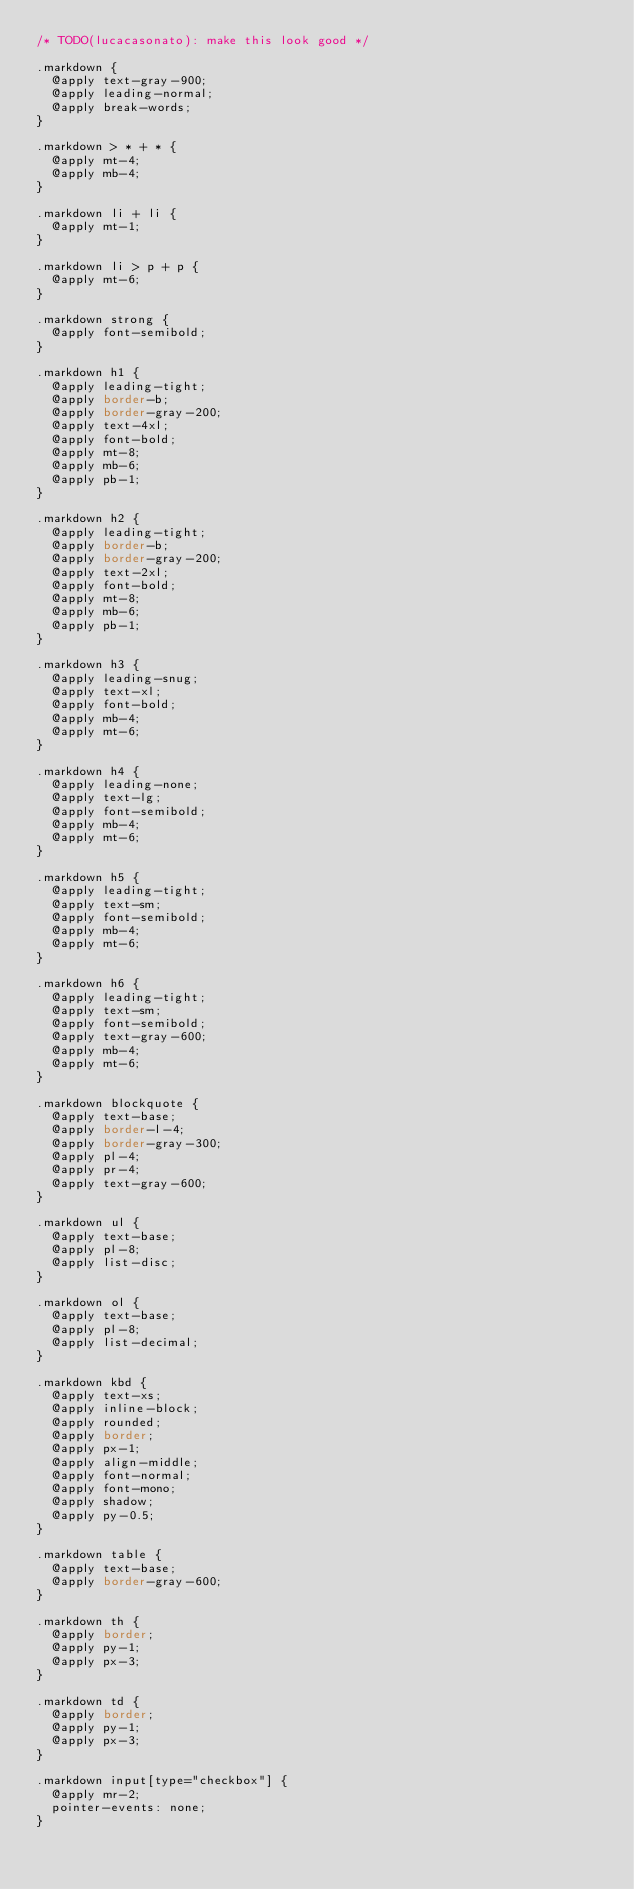Convert code to text. <code><loc_0><loc_0><loc_500><loc_500><_CSS_>/* TODO(lucacasonato): make this look good */

.markdown {
  @apply text-gray-900;
  @apply leading-normal;
  @apply break-words;
}

.markdown > * + * {
  @apply mt-4;
  @apply mb-4;
}

.markdown li + li {
  @apply mt-1;
}

.markdown li > p + p {
  @apply mt-6;
}

.markdown strong {
  @apply font-semibold;
}

.markdown h1 {
  @apply leading-tight;
  @apply border-b;
  @apply border-gray-200;
  @apply text-4xl;
  @apply font-bold;
  @apply mt-8;
  @apply mb-6;
  @apply pb-1;
}

.markdown h2 {
  @apply leading-tight;
  @apply border-b;
  @apply border-gray-200;
  @apply text-2xl;
  @apply font-bold;
  @apply mt-8;
  @apply mb-6;
  @apply pb-1;
}

.markdown h3 {
  @apply leading-snug;
  @apply text-xl;
  @apply font-bold;
  @apply mb-4;
  @apply mt-6;
}

.markdown h4 {
  @apply leading-none;
  @apply text-lg;
  @apply font-semibold;
  @apply mb-4;
  @apply mt-6;
}

.markdown h5 {
  @apply leading-tight;
  @apply text-sm;
  @apply font-semibold;
  @apply mb-4;
  @apply mt-6;
}

.markdown h6 {
  @apply leading-tight;
  @apply text-sm;
  @apply font-semibold;
  @apply text-gray-600;
  @apply mb-4;
  @apply mt-6;
}

.markdown blockquote {
  @apply text-base;
  @apply border-l-4;
  @apply border-gray-300;
  @apply pl-4;
  @apply pr-4;
  @apply text-gray-600;
}

.markdown ul {
  @apply text-base;
  @apply pl-8;
  @apply list-disc;
}

.markdown ol {
  @apply text-base;
  @apply pl-8;
  @apply list-decimal;
}

.markdown kbd {
  @apply text-xs;
  @apply inline-block;
  @apply rounded;
  @apply border;
  @apply px-1;
  @apply align-middle;
  @apply font-normal;
  @apply font-mono;
  @apply shadow;
  @apply py-0.5;
}

.markdown table {
  @apply text-base;
  @apply border-gray-600;
}

.markdown th {
  @apply border;
  @apply py-1;
  @apply px-3;
}

.markdown td {
  @apply border;
  @apply py-1;
  @apply px-3;
}

.markdown input[type="checkbox"] {
  @apply mr-2;
  pointer-events: none;
}
</code> 